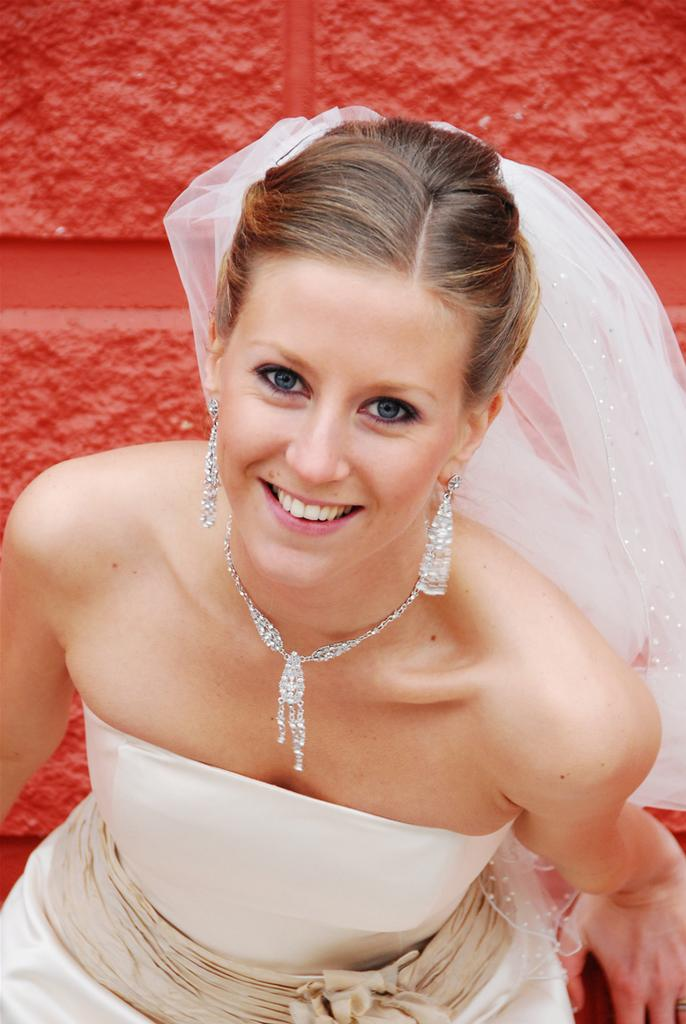Who is present in the image? There is a woman in the image. What is the woman wearing? The woman is wearing a white dress. What expression does the woman have? The woman is smiling. What color is the surface in the background of the image? The surface in the background of the image has an orange color. How much wealth does the woman possess in the image? There is no information about the woman's wealth in the image. Can you tell me how many times the woman kicks the ball in the image? There is no ball present in the image, so the woman cannot kick it. 